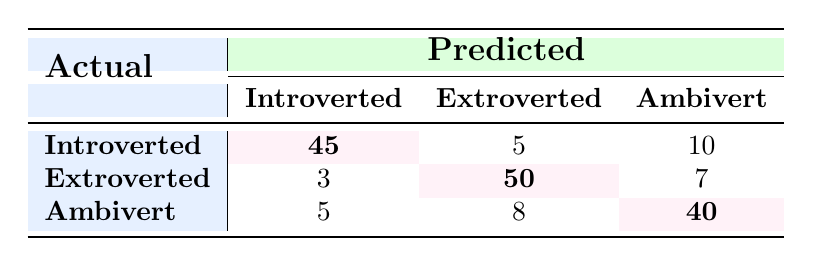What is the number of participants predicted as Introverted who actually are Introverted? In the table under the row 'Introverted' and the column 'Introverted', the value is 45. This indicates that 45 participants were correctly predicted as Introverted.
Answer: 45 What is the total number of Extroverted participants predicted correctly? To find the number of correctly predicted Extroverted participants, we look in the row 'Extroverted' and column 'Extroverted', which shows 50.
Answer: 50 How many participants predicted as Ambivert were actually Introverted? In the row 'Introverted' and column 'Ambivert', the table shows a count of 10. This indicates 10 participants who were predicted as Ambivert but were actually Introverted.
Answer: 10 Is the number of Extroverted participants predicted as Introverted greater than the number of Ambivert participants predicted as Extroverted? Looking at the table, the number of Extroverted participants predicted as Introverted is 3, and the number of Ambivert participants predicted as Extroverted is 8. Since 3 is not greater than 8, the statement is false.
Answer: No What is the overall accuracy of the model for this classification task? The overall accuracy is calculated by summing the correctly predicted values (45 + 50 + 40 = 135) and dividing by the total number of predictions (the sum of all values in the table, which is 45 + 5 + 10 + 3 + 50 + 7 + 5 + 8 + 40 = 173). Therefore, accuracy = 135 / 173 ≈ 0.7803 or 78.03%.
Answer: 78.03% How many participants were incorrectly predicted as Ambivert? To find the incorrectly predicted Ambivert participants, we sum the values in the 'Ambivert' column excluding the correct prediction: 5 (Introverted) + 8 (Extroverted) = 13. Therefore, 13 participants were incorrectly predicted as Ambivert.
Answer: 13 Which group had the highest misclassification? To identify which group had the highest misclassification, we compare the misclassifications for each actual class: for Introverted, misclassified as Extroverted and Ambivert: 5 + 10 = 15; for Extroverted: 3 + 7 = 10; for Ambivert: 5 + 8 = 13. The highest is 15 for Introverted.
Answer: Introverted How many more participants were predicted as Introverted compared to Extroverted? In the table, the predicted values show for Introverted: (45 + 5 + 10 = 60) and for Extroverted: (3 + 50 + 7 = 60). So, the difference in predicted numbers is 60 - 60 = 0. Thus, there are no more participants predicted as one group compared to the other.
Answer: 0 How does the number of participants misclassified as Introverted compare to those misclassified as Ambivert? Misclassified Introverted (5 + 10 = 15) and misclassified Ambivert (5 + 8 = 13). Thus, 15 (Introverted) is greater than 13 (Ambivert), indicating more participants misclassified as Introverted.
Answer: Introverted is greater 